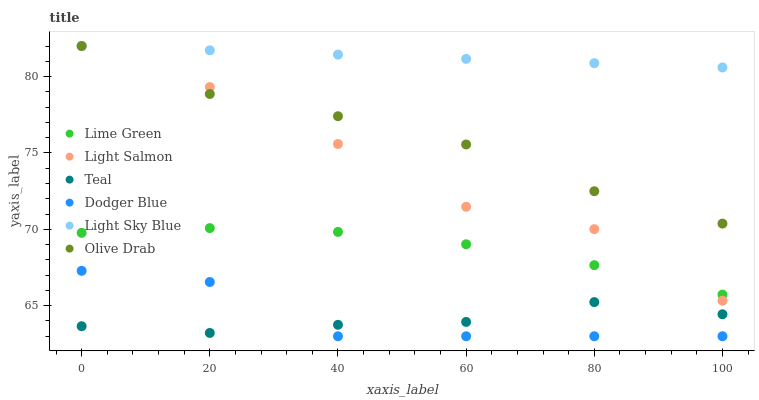Does Teal have the minimum area under the curve?
Answer yes or no. Yes. Does Light Sky Blue have the maximum area under the curve?
Answer yes or no. Yes. Does Dodger Blue have the minimum area under the curve?
Answer yes or no. No. Does Dodger Blue have the maximum area under the curve?
Answer yes or no. No. Is Light Sky Blue the smoothest?
Answer yes or no. Yes. Is Light Salmon the roughest?
Answer yes or no. Yes. Is Dodger Blue the smoothest?
Answer yes or no. No. Is Dodger Blue the roughest?
Answer yes or no. No. Does Dodger Blue have the lowest value?
Answer yes or no. Yes. Does Light Sky Blue have the lowest value?
Answer yes or no. No. Does Olive Drab have the highest value?
Answer yes or no. Yes. Does Dodger Blue have the highest value?
Answer yes or no. No. Is Lime Green less than Olive Drab?
Answer yes or no. Yes. Is Light Sky Blue greater than Dodger Blue?
Answer yes or no. Yes. Does Teal intersect Dodger Blue?
Answer yes or no. Yes. Is Teal less than Dodger Blue?
Answer yes or no. No. Is Teal greater than Dodger Blue?
Answer yes or no. No. Does Lime Green intersect Olive Drab?
Answer yes or no. No. 